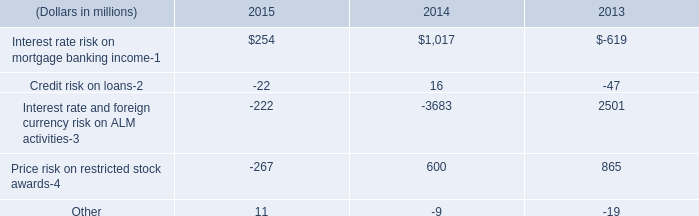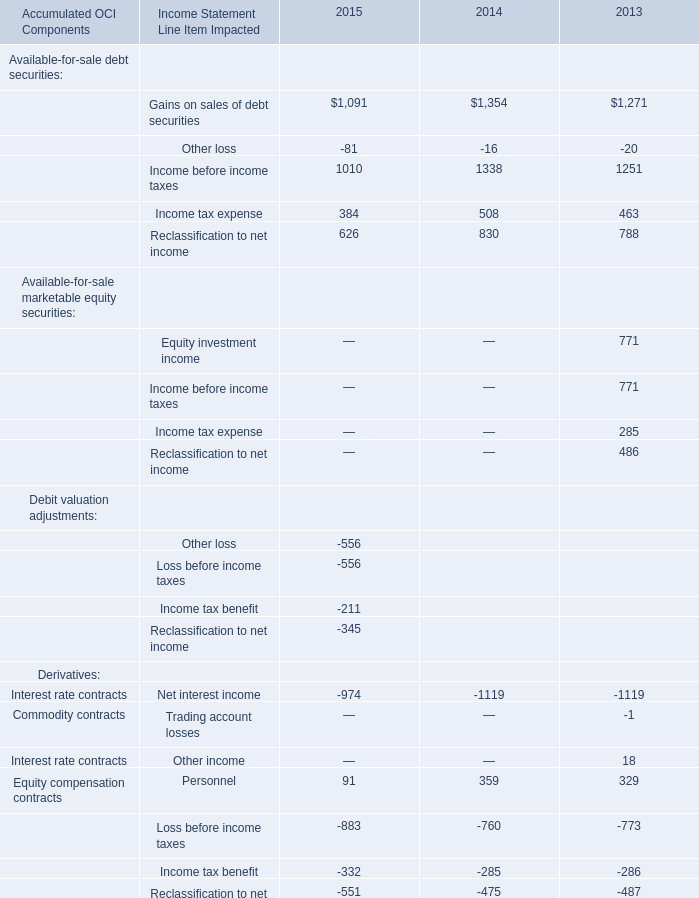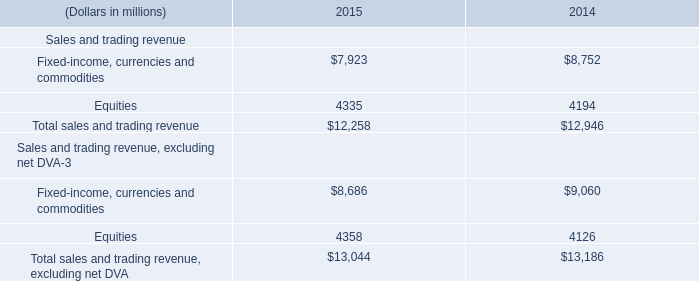What's the sum of Available-for-sale debt securities without those other loss smaller than 2000 in 2015? 
Computations: (((1091 + 1010) + 384) + 626)
Answer: 3111.0. 